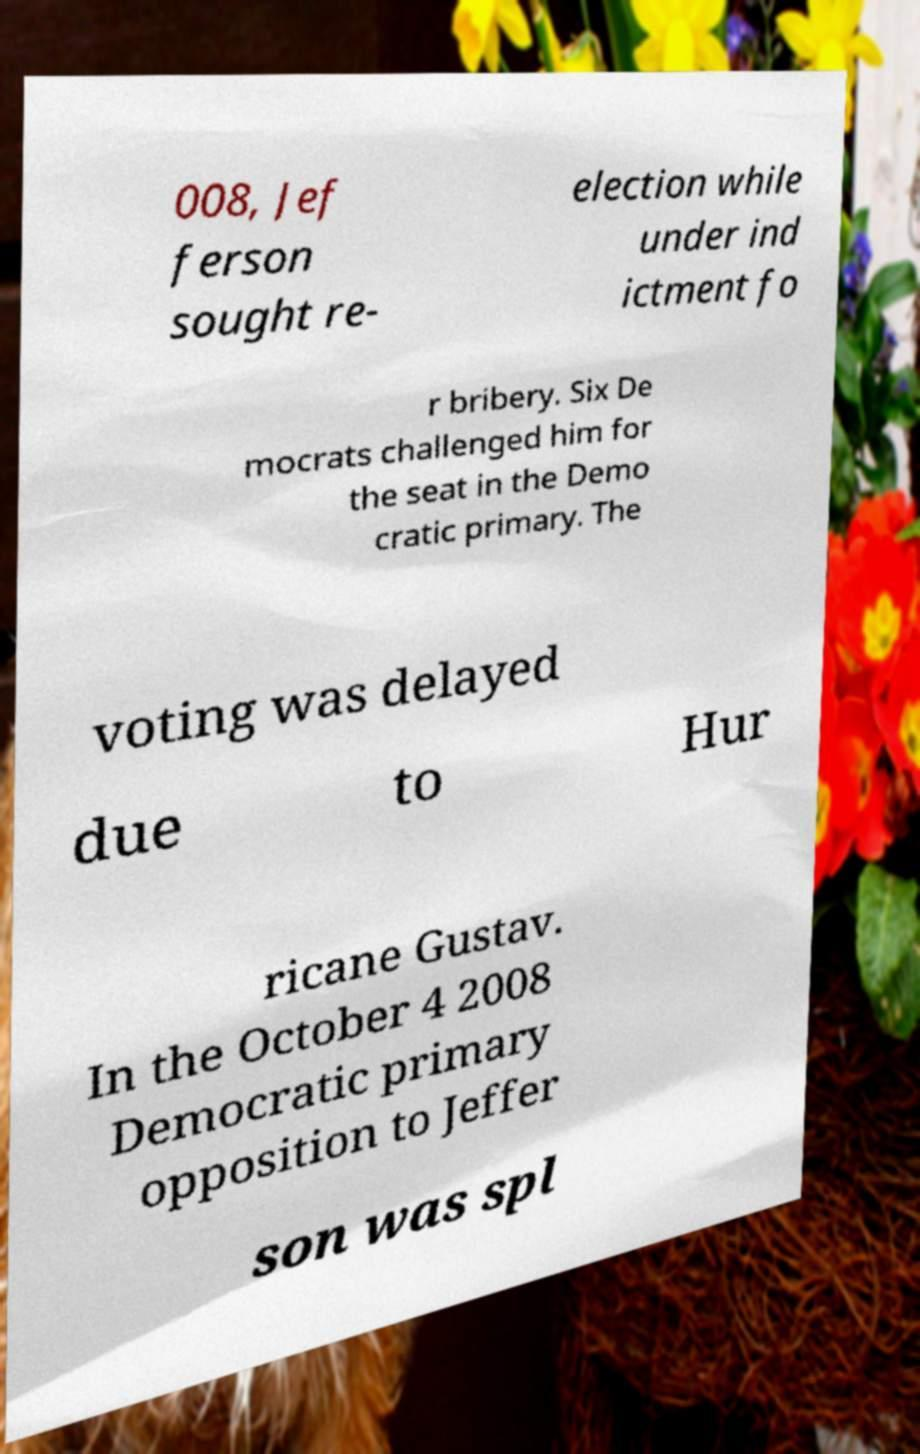Could you assist in decoding the text presented in this image and type it out clearly? 008, Jef ferson sought re- election while under ind ictment fo r bribery. Six De mocrats challenged him for the seat in the Demo cratic primary. The voting was delayed due to Hur ricane Gustav. In the October 4 2008 Democratic primary opposition to Jeffer son was spl 